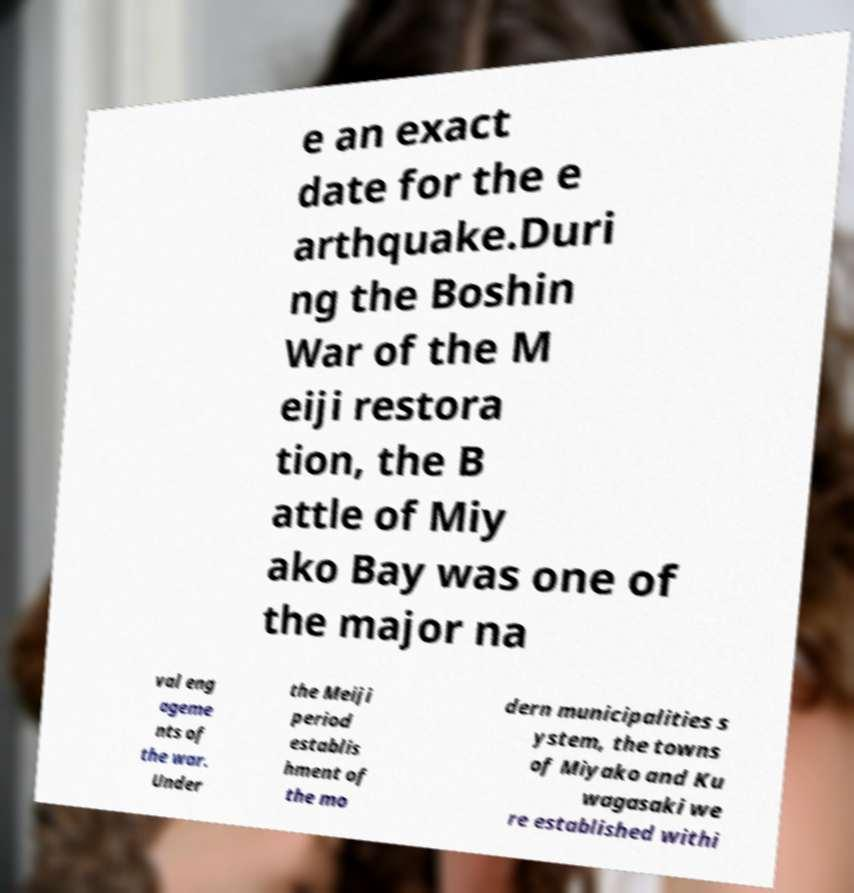Please identify and transcribe the text found in this image. e an exact date for the e arthquake.Duri ng the Boshin War of the M eiji restora tion, the B attle of Miy ako Bay was one of the major na val eng ageme nts of the war. Under the Meiji period establis hment of the mo dern municipalities s ystem, the towns of Miyako and Ku wagasaki we re established withi 